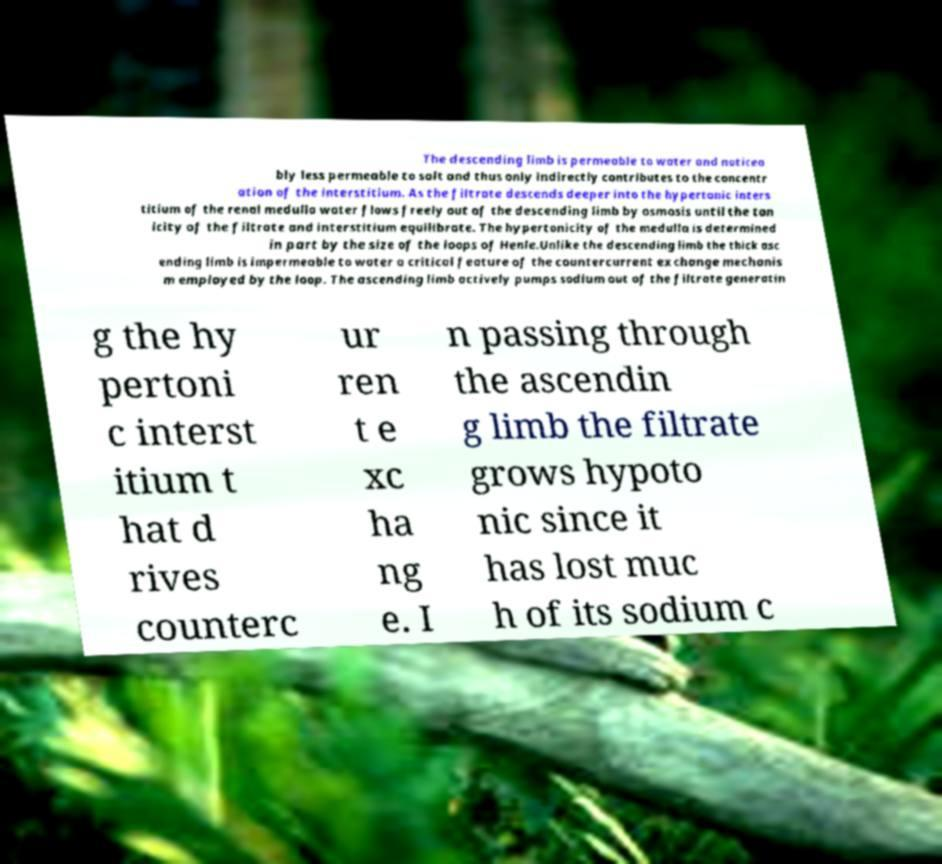Could you extract and type out the text from this image? The descending limb is permeable to water and noticea bly less permeable to salt and thus only indirectly contributes to the concentr ation of the interstitium. As the filtrate descends deeper into the hypertonic inters titium of the renal medulla water flows freely out of the descending limb by osmosis until the ton icity of the filtrate and interstitium equilibrate. The hypertonicity of the medulla is determined in part by the size of the loops of Henle.Unlike the descending limb the thick asc ending limb is impermeable to water a critical feature of the countercurrent exchange mechanis m employed by the loop. The ascending limb actively pumps sodium out of the filtrate generatin g the hy pertoni c interst itium t hat d rives counterc ur ren t e xc ha ng e. I n passing through the ascendin g limb the filtrate grows hypoto nic since it has lost muc h of its sodium c 